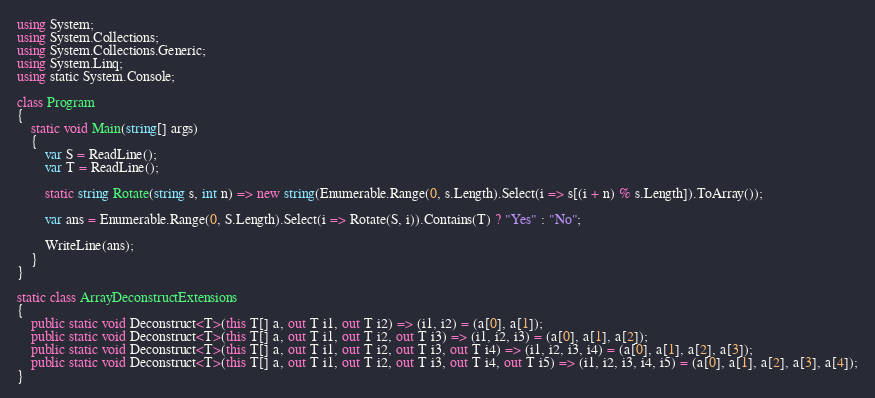<code> <loc_0><loc_0><loc_500><loc_500><_C#_>using System;
using System.Collections;
using System.Collections.Generic;
using System.Linq;
using static System.Console;

class Program
{
    static void Main(string[] args)
    {
        var S = ReadLine();
        var T = ReadLine();

        static string Rotate(string s, int n) => new string(Enumerable.Range(0, s.Length).Select(i => s[(i + n) % s.Length]).ToArray());

        var ans = Enumerable.Range(0, S.Length).Select(i => Rotate(S, i)).Contains(T) ? "Yes" : "No";

        WriteLine(ans);
    }
}

static class ArrayDeconstructExtensions
{
    public static void Deconstruct<T>(this T[] a, out T i1, out T i2) => (i1, i2) = (a[0], a[1]);
    public static void Deconstruct<T>(this T[] a, out T i1, out T i2, out T i3) => (i1, i2, i3) = (a[0], a[1], a[2]);
    public static void Deconstruct<T>(this T[] a, out T i1, out T i2, out T i3, out T i4) => (i1, i2, i3, i4) = (a[0], a[1], a[2], a[3]);
    public static void Deconstruct<T>(this T[] a, out T i1, out T i2, out T i3, out T i4, out T i5) => (i1, i2, i3, i4, i5) = (a[0], a[1], a[2], a[3], a[4]);
}
</code> 